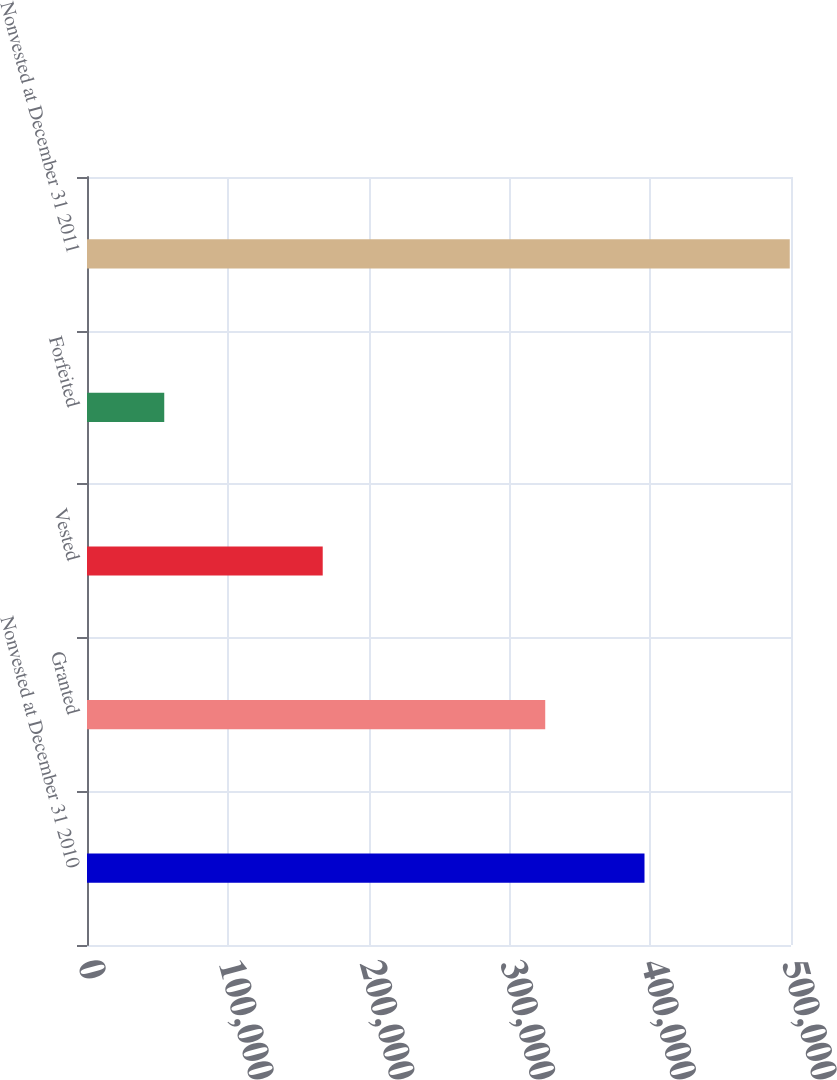Convert chart to OTSL. <chart><loc_0><loc_0><loc_500><loc_500><bar_chart><fcel>Nonvested at December 31 2010<fcel>Granted<fcel>Vested<fcel>Forfeited<fcel>Nonvested at December 31 2011<nl><fcel>395950<fcel>325447<fcel>167414<fcel>54864<fcel>499119<nl></chart> 